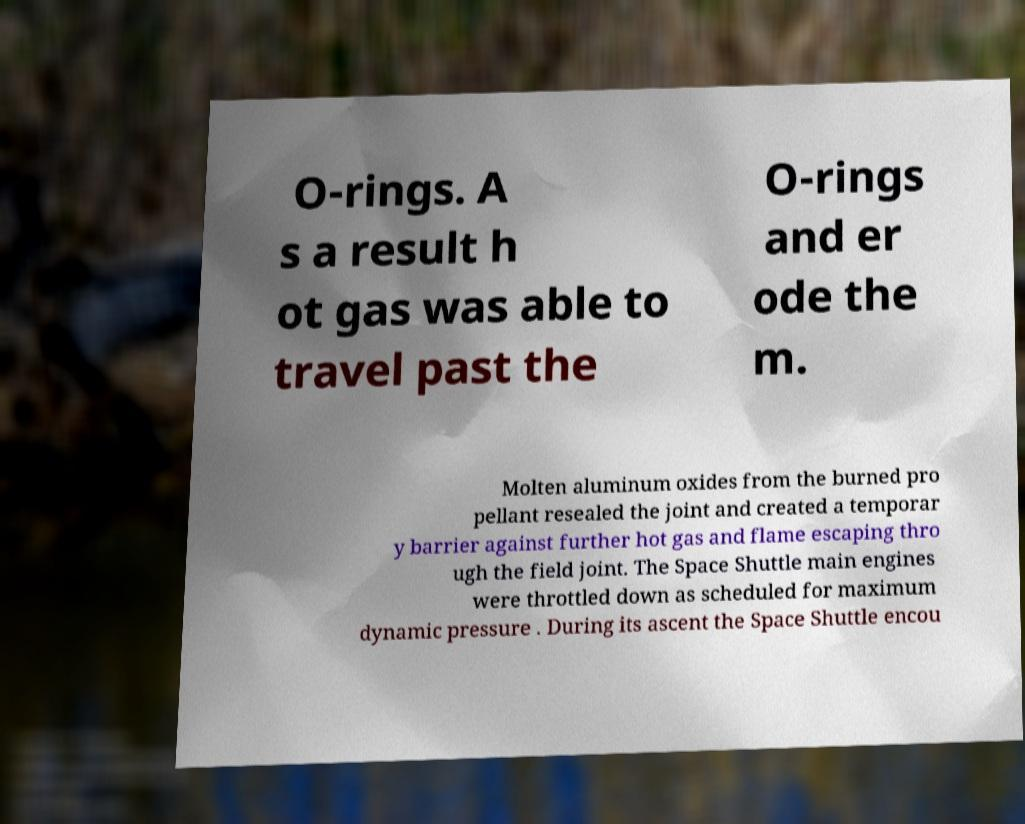Please identify and transcribe the text found in this image. O-rings. A s a result h ot gas was able to travel past the O-rings and er ode the m. Molten aluminum oxides from the burned pro pellant resealed the joint and created a temporar y barrier against further hot gas and flame escaping thro ugh the field joint. The Space Shuttle main engines were throttled down as scheduled for maximum dynamic pressure . During its ascent the Space Shuttle encou 